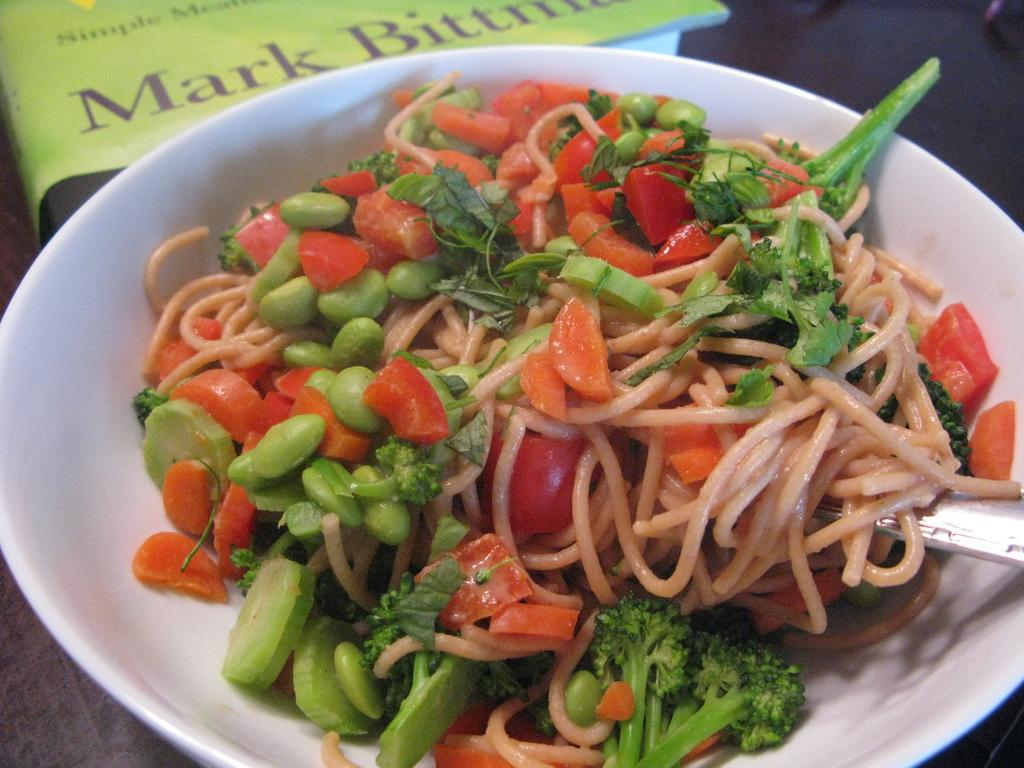What is in the bowl that is visible in the image? There is food in a bowl in the image. Where is the bowl located in the image? The bowl is placed on a table. What other object can be seen in the image besides the bowl? There is a book visible at the top of the image. What type of sponge is being used to clean the book in the image? There is no sponge present in the image, and the book is not being cleaned. 